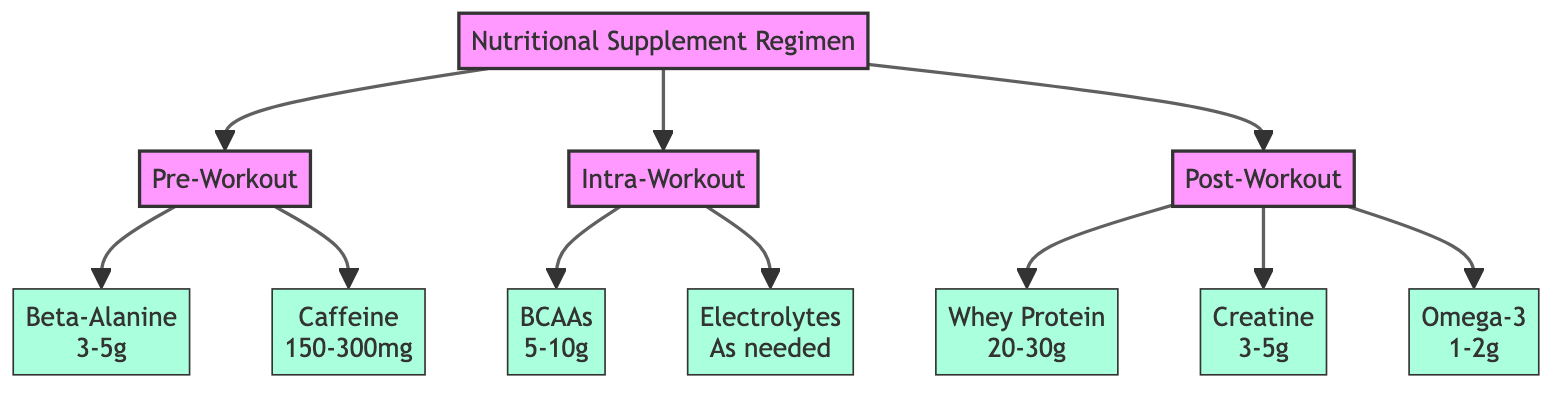What is the first phase in the Nutritional Supplement Regimen? The diagram clearly indicates three phases: Pre-Workout, Intra-Workout, and Post-Workout. The first phase listed in the pathway is Pre-Workout.
Answer: Pre-Workout How many supplements are listed in the Post-Workout phase? In the diagram, the Post-Workout phase connects to three supplements: Whey Protein, Creatine, and Omega-3 Fatty Acids. Therefore, there are three supplements listed under this phase.
Answer: 3 What is the dosage range for Beta-Alanine? Looking at the supplement node for Beta-Alanine, the dosage range specified is 3-5 grams. This information is directly shown in the diagram connected to the Pre-Workout phase.
Answer: 3-5 grams Which supplement is associated with endurance improvement? The diagram specifies that Beta-Alanine improves endurance, as indicated in its benefit description under the Pre-Workout phase.
Answer: Beta-Alanine What is the benefit of taking BCAAs during the workout? The diagram states that BCAAs help to reduce muscle soreness and prevent muscle breakdown, which is explicitly listed in the benefit section for the Intra-Workout phase.
Answer: Reduces muscle soreness What type of nutrient is Omega-3 classified as? In the diagram, Omega-3 is presented in the Post-Workout phase and is noted for reducing inflammation and supporting joint health. It is classified as a fatty acid.
Answer: Fatty acid What is the main goal of the Nutritional Supplement Regimen? The overarching goal of the Nutritional Supplement Regimen as represented in the diagram is to provide a structured intake of supplements before, during, and after workouts to optimize recovery and performance.
Answer: Optimize recovery and performance What phase includes Electrolytes? The diagram connects Electrolytes as a supplement under the Intra-Workout phase, indicating its inclusion in that specific timing.
Answer: Intra-Workout What is the dosage of Caffeine recommended? The diagram clearly shows that the recommended dosage for Caffeine in the Pre-Workout phase is between 150-300 mg.
Answer: 150-300 mg 